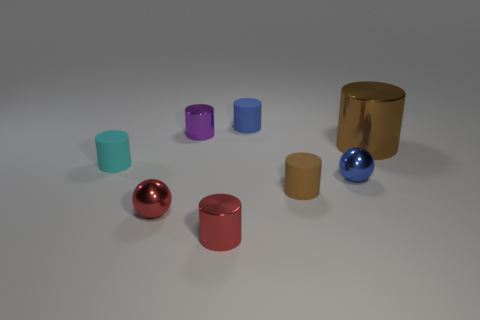There is a metallic cylinder in front of the large metallic thing; does it have the same color as the big object?
Give a very brief answer. No. How many metallic things are cyan objects or big red cylinders?
Offer a terse response. 0. Is there any other thing that has the same size as the cyan rubber cylinder?
Ensure brevity in your answer.  Yes. What color is the other small sphere that is the same material as the blue ball?
Ensure brevity in your answer.  Red. How many blocks are either cyan matte things or purple metallic things?
Your answer should be very brief. 0. What number of things are either red shiny balls or small matte things that are behind the blue metallic object?
Give a very brief answer. 3. Is there a large green cube?
Ensure brevity in your answer.  No. How many small things have the same color as the large metal cylinder?
Your response must be concise. 1. There is a tiny thing that is the same color as the big metallic cylinder; what is it made of?
Keep it short and to the point. Rubber. There is a object that is behind the shiny thing that is behind the big metal thing; what size is it?
Provide a short and direct response. Small. 